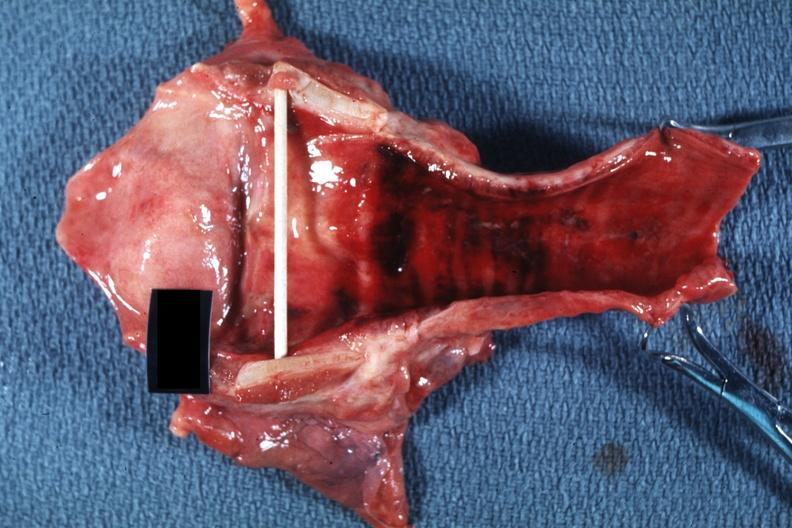why does this image show good example probably?
Answer the question using a single word or phrase. Due to intubation 